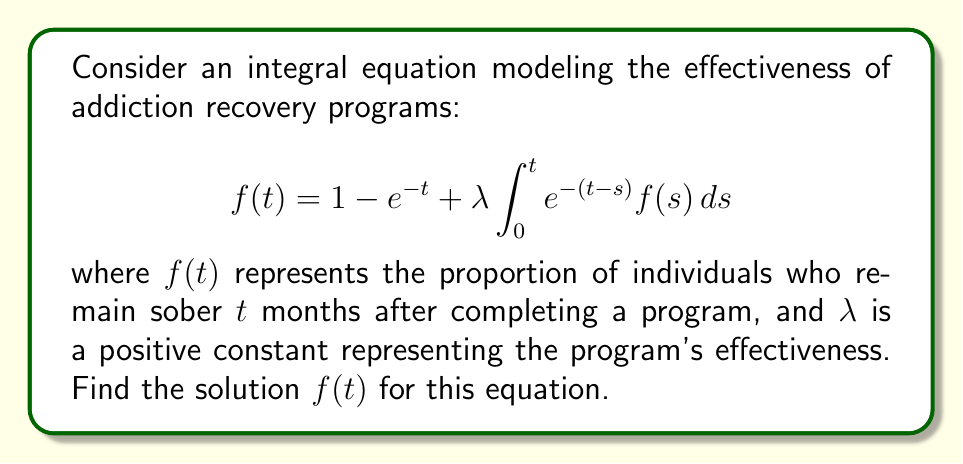Show me your answer to this math problem. 1) First, we recognize this as a Volterra integral equation of the second kind.

2) To solve this, we'll use the Laplace transform method. Let $F(s)$ be the Laplace transform of $f(t)$.

3) Taking the Laplace transform of both sides:

   $$F(s) = \frac{1}{s} - \frac{1}{s+1} + \lambda \cdot \frac{1}{s+1} \cdot F(s)$$

4) Rearranging terms:

   $$F(s)(1 - \frac{\lambda}{s+1}) = \frac{1}{s} - \frac{1}{s+1}$$

5) Solving for $F(s)$:

   $$F(s) = \frac{\frac{1}{s} - \frac{1}{s+1}}{1 - \frac{\lambda}{s+1}} = \frac{1}{s+1-\lambda}$$

6) Now we need to take the inverse Laplace transform. We recognize this as the transform of an exponential function:

   $$f(t) = e^{(λ-1)t}$$

7) This is our solution. It represents the proportion of individuals remaining sober after time $t$, given a program effectiveness of $\lambda$.
Answer: $f(t) = e^{(λ-1)t}$ 